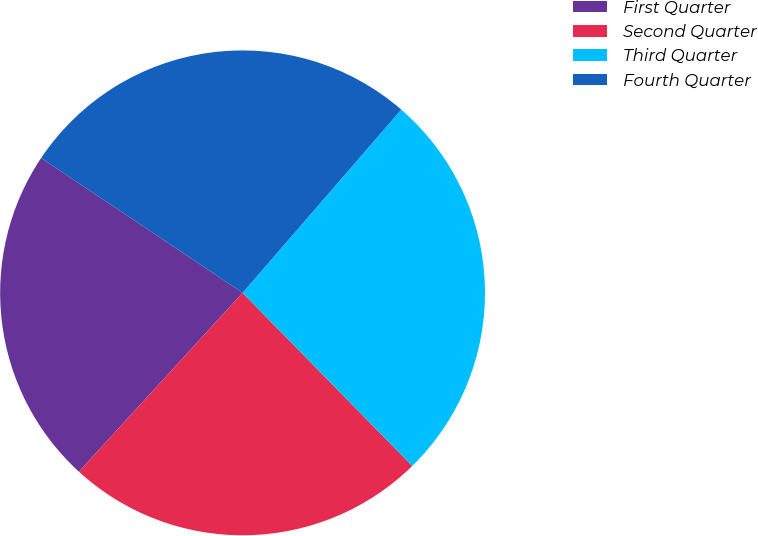Convert chart. <chart><loc_0><loc_0><loc_500><loc_500><pie_chart><fcel>First Quarter<fcel>Second Quarter<fcel>Third Quarter<fcel>Fourth Quarter<nl><fcel>22.59%<fcel>24.14%<fcel>26.3%<fcel>26.97%<nl></chart> 